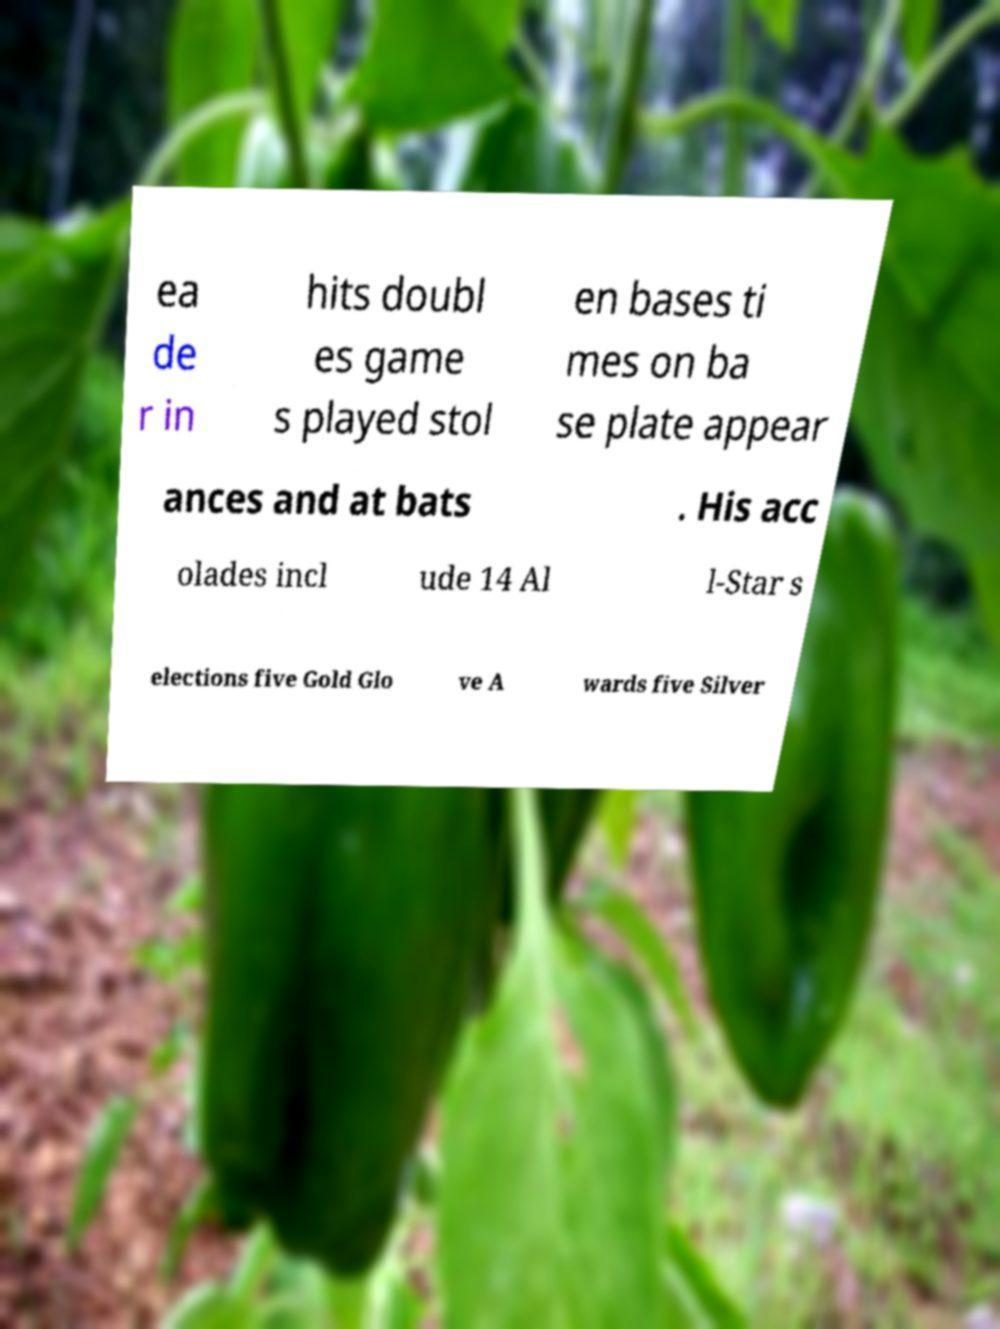I need the written content from this picture converted into text. Can you do that? ea de r in hits doubl es game s played stol en bases ti mes on ba se plate appear ances and at bats . His acc olades incl ude 14 Al l-Star s elections five Gold Glo ve A wards five Silver 